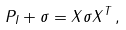<formula> <loc_0><loc_0><loc_500><loc_500>P _ { I } + \sigma = X \sigma X ^ { T } \, ,</formula> 